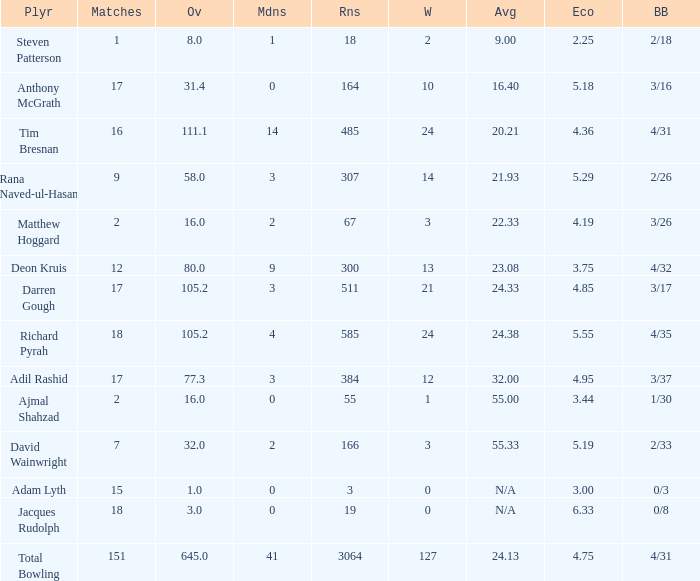What is the lowest Overs with a Run that is 18? 8.0. 